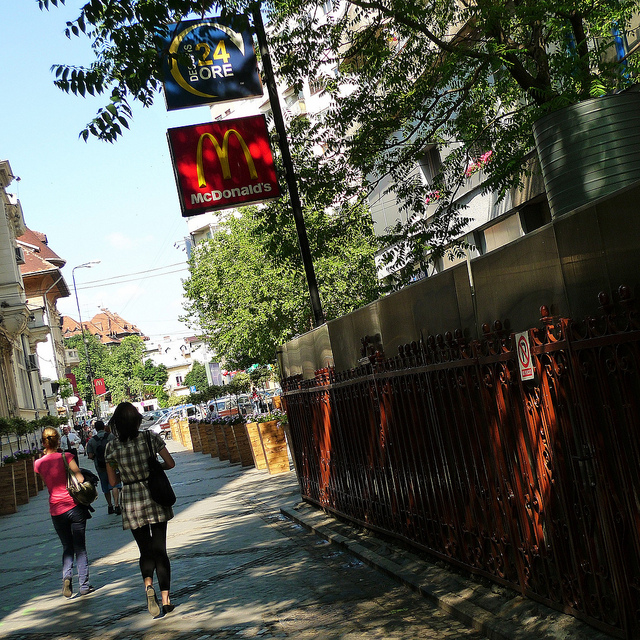Please transcribe the text in this image. McDonald's MCDonald's 24 ORE 